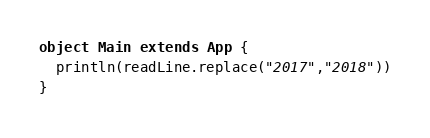<code> <loc_0><loc_0><loc_500><loc_500><_Scala_>object Main extends App {
  println(readLine.replace("2017","2018"))
}</code> 